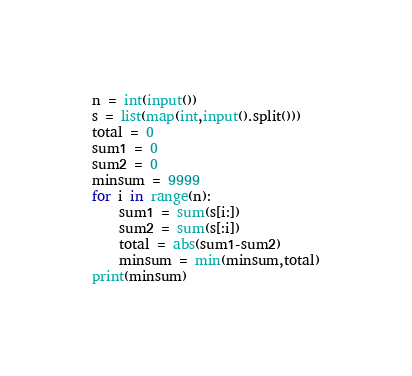Convert code to text. <code><loc_0><loc_0><loc_500><loc_500><_Python_>n = int(input())
s = list(map(int,input().split()))
total = 0
sum1 = 0
sum2 = 0
minsum = 9999
for i in range(n):
    sum1 = sum(s[i:])
    sum2 = sum(s[:i])
    total = abs(sum1-sum2)
    minsum = min(minsum,total)
print(minsum)</code> 